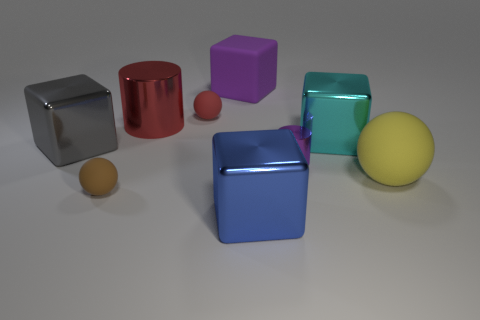The small cylinder that is made of the same material as the cyan block is what color?
Offer a terse response. Purple. What is the purple object that is in front of the metal thing left of the tiny brown object made of?
Your answer should be compact. Metal. What number of objects are red spheres that are behind the yellow rubber object or things on the right side of the large red metal cylinder?
Your answer should be compact. 6. There is a shiny cube in front of the big rubber object that is in front of the metal block that is left of the small brown matte thing; what size is it?
Your answer should be very brief. Large. Are there an equal number of cylinders left of the large cylinder and large gray rubber cubes?
Keep it short and to the point. Yes. Is there anything else that has the same shape as the large purple matte object?
Your answer should be compact. Yes. Is the shape of the brown rubber thing the same as the big thing to the left of the large metallic cylinder?
Provide a short and direct response. No. The brown thing that is the same shape as the big yellow thing is what size?
Your answer should be very brief. Small. What number of other things are the same material as the big blue thing?
Ensure brevity in your answer.  4. What material is the blue object?
Offer a very short reply. Metal. 